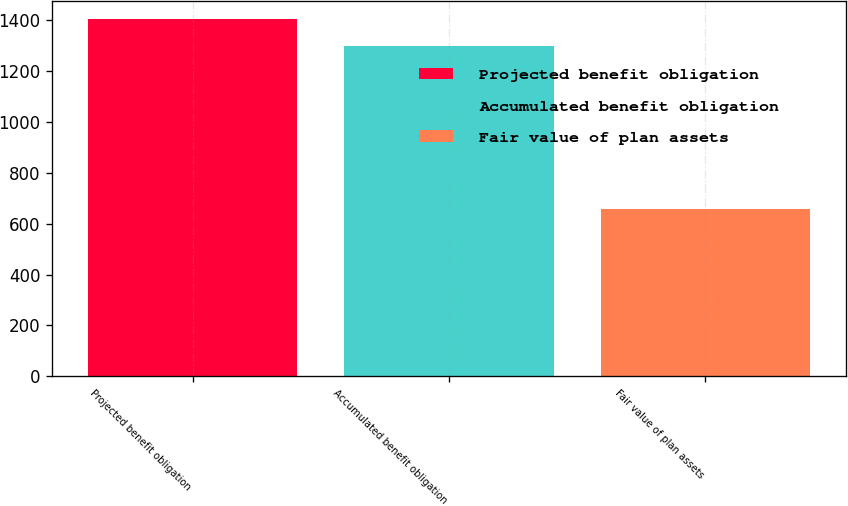Convert chart. <chart><loc_0><loc_0><loc_500><loc_500><bar_chart><fcel>Projected benefit obligation<fcel>Accumulated benefit obligation<fcel>Fair value of plan assets<nl><fcel>1405<fcel>1300<fcel>657<nl></chart> 